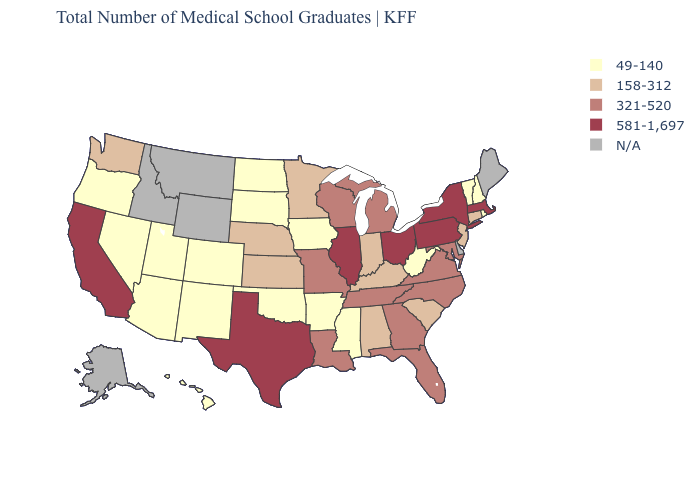What is the lowest value in the South?
Concise answer only. 49-140. What is the value of South Dakota?
Short answer required. 49-140. Which states have the lowest value in the South?
Keep it brief. Arkansas, Mississippi, Oklahoma, West Virginia. Is the legend a continuous bar?
Concise answer only. No. Which states hav the highest value in the Northeast?
Be succinct. Massachusetts, New York, Pennsylvania. Name the states that have a value in the range 321-520?
Write a very short answer. Florida, Georgia, Louisiana, Maryland, Michigan, Missouri, North Carolina, Tennessee, Virginia, Wisconsin. Name the states that have a value in the range 158-312?
Answer briefly. Alabama, Connecticut, Indiana, Kansas, Kentucky, Minnesota, Nebraska, New Jersey, South Carolina, Washington. What is the value of Delaware?
Write a very short answer. N/A. Name the states that have a value in the range 581-1,697?
Keep it brief. California, Illinois, Massachusetts, New York, Ohio, Pennsylvania, Texas. Name the states that have a value in the range 158-312?
Keep it brief. Alabama, Connecticut, Indiana, Kansas, Kentucky, Minnesota, Nebraska, New Jersey, South Carolina, Washington. Which states have the lowest value in the West?
Concise answer only. Arizona, Colorado, Hawaii, Nevada, New Mexico, Oregon, Utah. Does the map have missing data?
Write a very short answer. Yes. Does Pennsylvania have the lowest value in the Northeast?
Short answer required. No. 